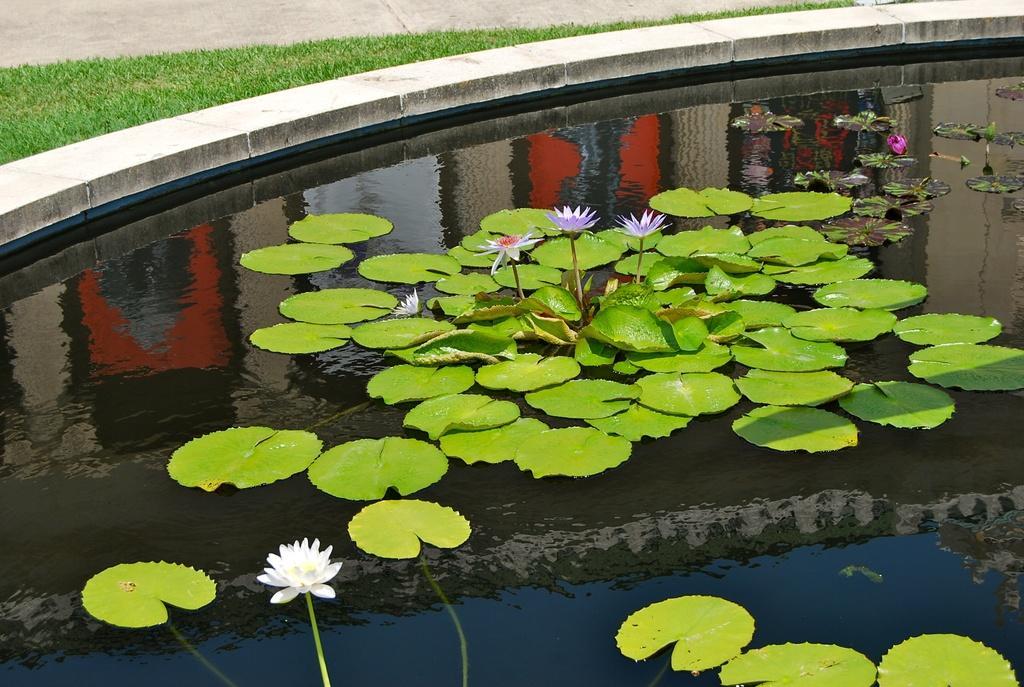Could you give a brief overview of what you see in this image? In this image we can see lotus and lotus leaves in the pond. Here we can see the grass. 